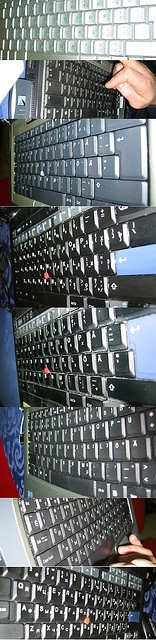Describe the objects in this image and their specific colors. I can see keyboard in darkgreen, black, gray, lavender, and darkgray tones, keyboard in darkgreen, black, gray, white, and darkgray tones, keyboard in darkgreen, gray, darkgray, black, and white tones, keyboard in darkgreen, gray, black, darkgray, and lightgray tones, and keyboard in darkgreen, black, gray, darkgray, and white tones in this image. 